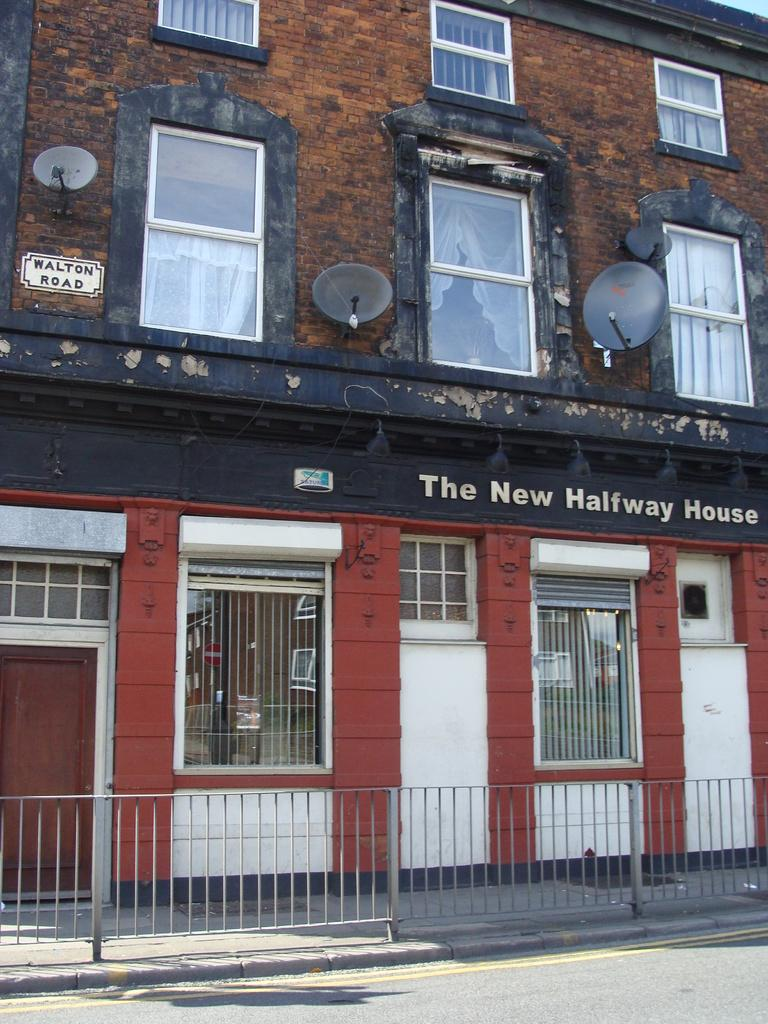What type of structure is visible in the image? There is a building in the image. What features can be seen on the building? The building has doors and windows. Can you describe an object in the middle of the image? There is a curtain in the middle of the image. What type of ornament is hanging from the jar in the image? There is no jar or ornament present in the image. How does the building walk in the image? Buildings do not walk; they are stationary structures. 